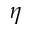Convert formula to latex. <formula><loc_0><loc_0><loc_500><loc_500>\eta</formula> 